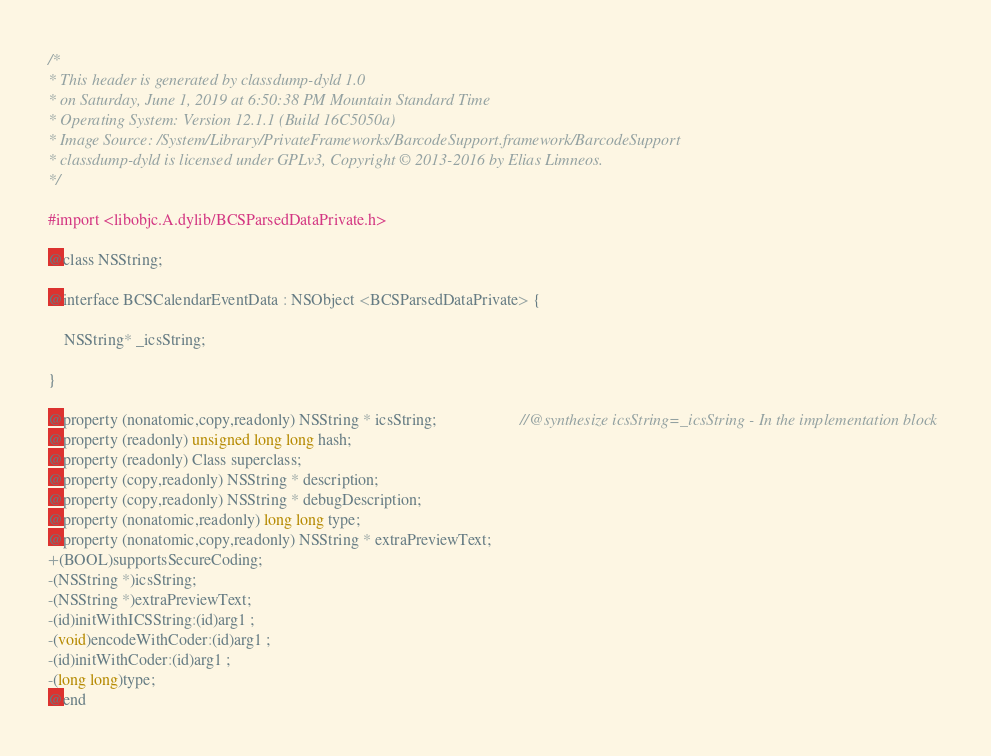<code> <loc_0><loc_0><loc_500><loc_500><_C_>/*
* This header is generated by classdump-dyld 1.0
* on Saturday, June 1, 2019 at 6:50:38 PM Mountain Standard Time
* Operating System: Version 12.1.1 (Build 16C5050a)
* Image Source: /System/Library/PrivateFrameworks/BarcodeSupport.framework/BarcodeSupport
* classdump-dyld is licensed under GPLv3, Copyright © 2013-2016 by Elias Limneos.
*/

#import <libobjc.A.dylib/BCSParsedDataPrivate.h>

@class NSString;

@interface BCSCalendarEventData : NSObject <BCSParsedDataPrivate> {

	NSString* _icsString;

}

@property (nonatomic,copy,readonly) NSString * icsString;                     //@synthesize icsString=_icsString - In the implementation block
@property (readonly) unsigned long long hash; 
@property (readonly) Class superclass; 
@property (copy,readonly) NSString * description; 
@property (copy,readonly) NSString * debugDescription; 
@property (nonatomic,readonly) long long type; 
@property (nonatomic,copy,readonly) NSString * extraPreviewText; 
+(BOOL)supportsSecureCoding;
-(NSString *)icsString;
-(NSString *)extraPreviewText;
-(id)initWithICSString:(id)arg1 ;
-(void)encodeWithCoder:(id)arg1 ;
-(id)initWithCoder:(id)arg1 ;
-(long long)type;
@end

</code> 